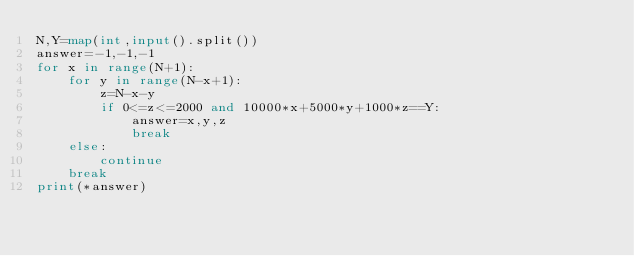Convert code to text. <code><loc_0><loc_0><loc_500><loc_500><_Python_>N,Y=map(int,input().split())
answer=-1,-1,-1
for x in range(N+1):
    for y in range(N-x+1):
        z=N-x-y
        if 0<=z<=2000 and 10000*x+5000*y+1000*z==Y:
            answer=x,y,z
            break
    else:
        continue
    break
print(*answer)</code> 